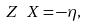Convert formula to latex. <formula><loc_0><loc_0><loc_500><loc_500>Z \ X & = - \eta ,</formula> 